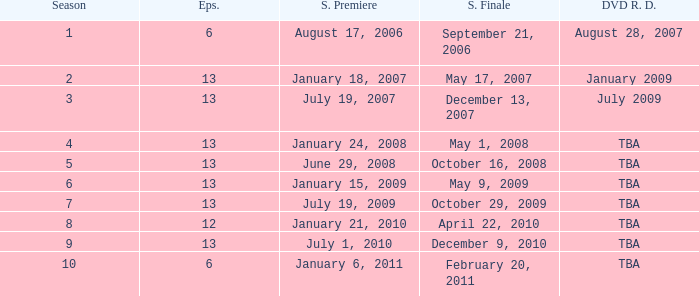Which season had fewer than 13 episodes and aired its season finale on February 20, 2011? 1.0. 